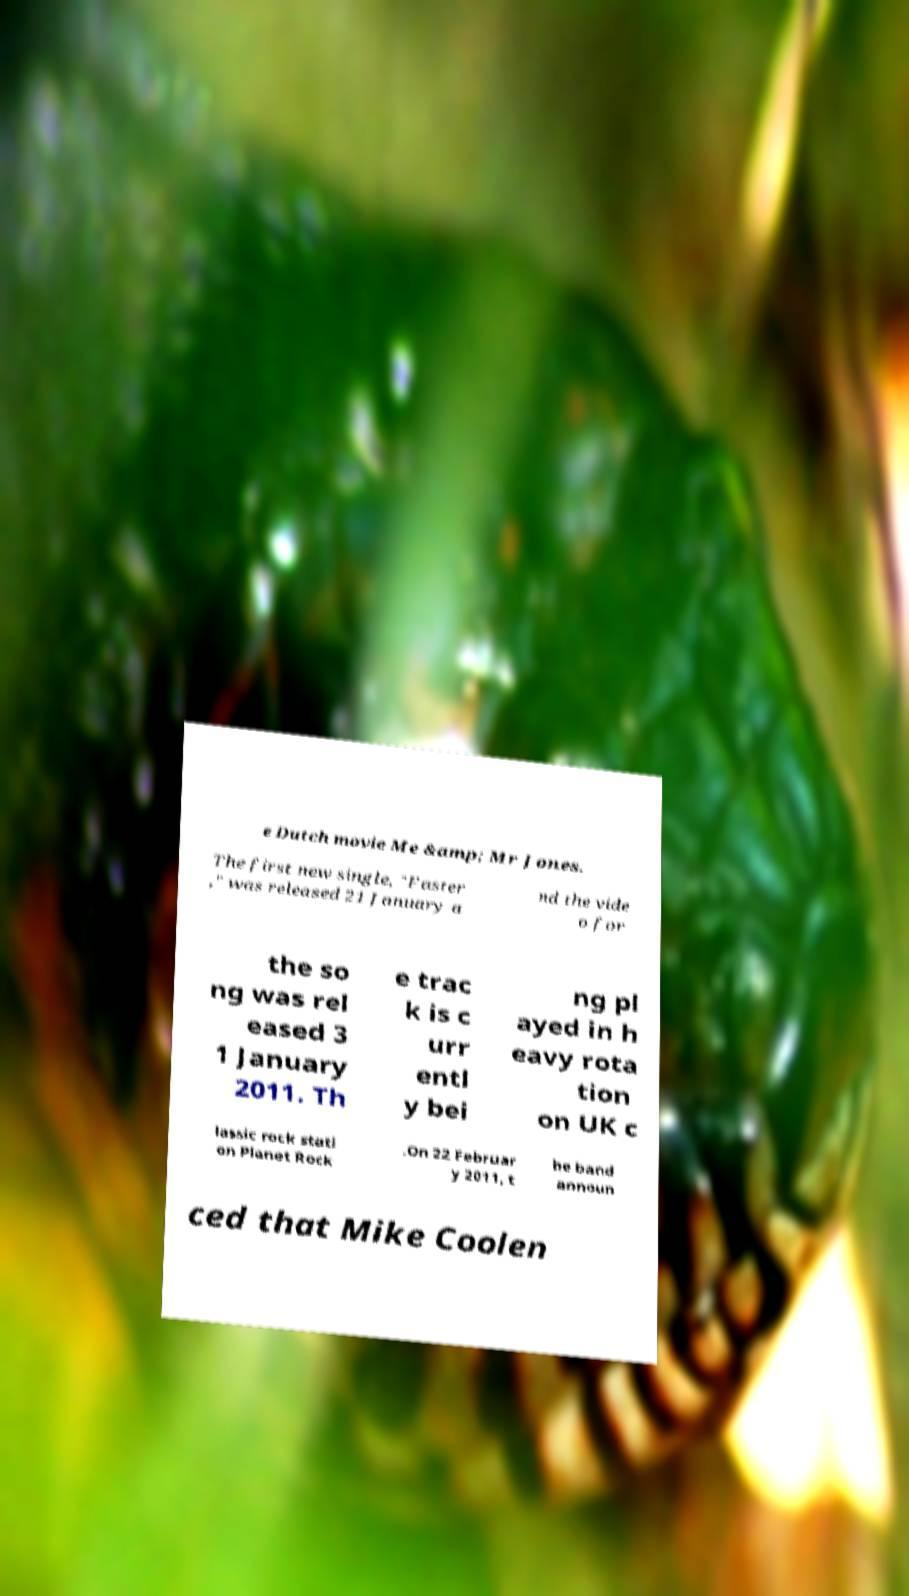What messages or text are displayed in this image? I need them in a readable, typed format. e Dutch movie Me &amp; Mr Jones. The first new single, "Faster ," was released 21 January a nd the vide o for the so ng was rel eased 3 1 January 2011. Th e trac k is c urr entl y bei ng pl ayed in h eavy rota tion on UK c lassic rock stati on Planet Rock .On 22 Februar y 2011, t he band announ ced that Mike Coolen 